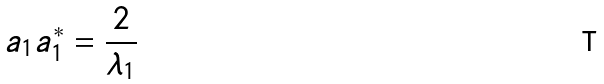<formula> <loc_0><loc_0><loc_500><loc_500>a _ { 1 } a _ { 1 } ^ { * } = \frac { 2 } { \lambda _ { 1 } }</formula> 